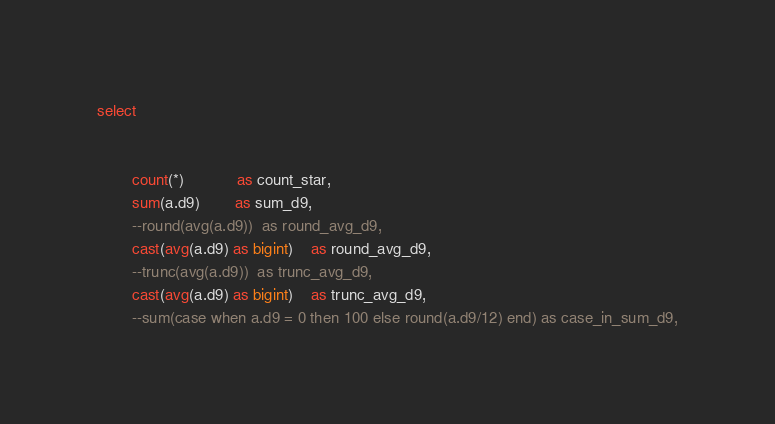Convert code to text. <code><loc_0><loc_0><loc_500><loc_500><_SQL_>select

				
		count(*)			as count_star,
 		sum(a.d9)		as sum_d9,
 		--round(avg(a.d9))	as round_avg_d9,
 		cast(avg(a.d9) as bigint)	as round_avg_d9,
 		--trunc(avg(a.d9))	as trunc_avg_d9,
 		cast(avg(a.d9) as bigint)	as trunc_avg_d9,
 		--sum(case when a.d9 = 0 then 100 else round(a.d9/12) end) as case_in_sum_d9,</code> 